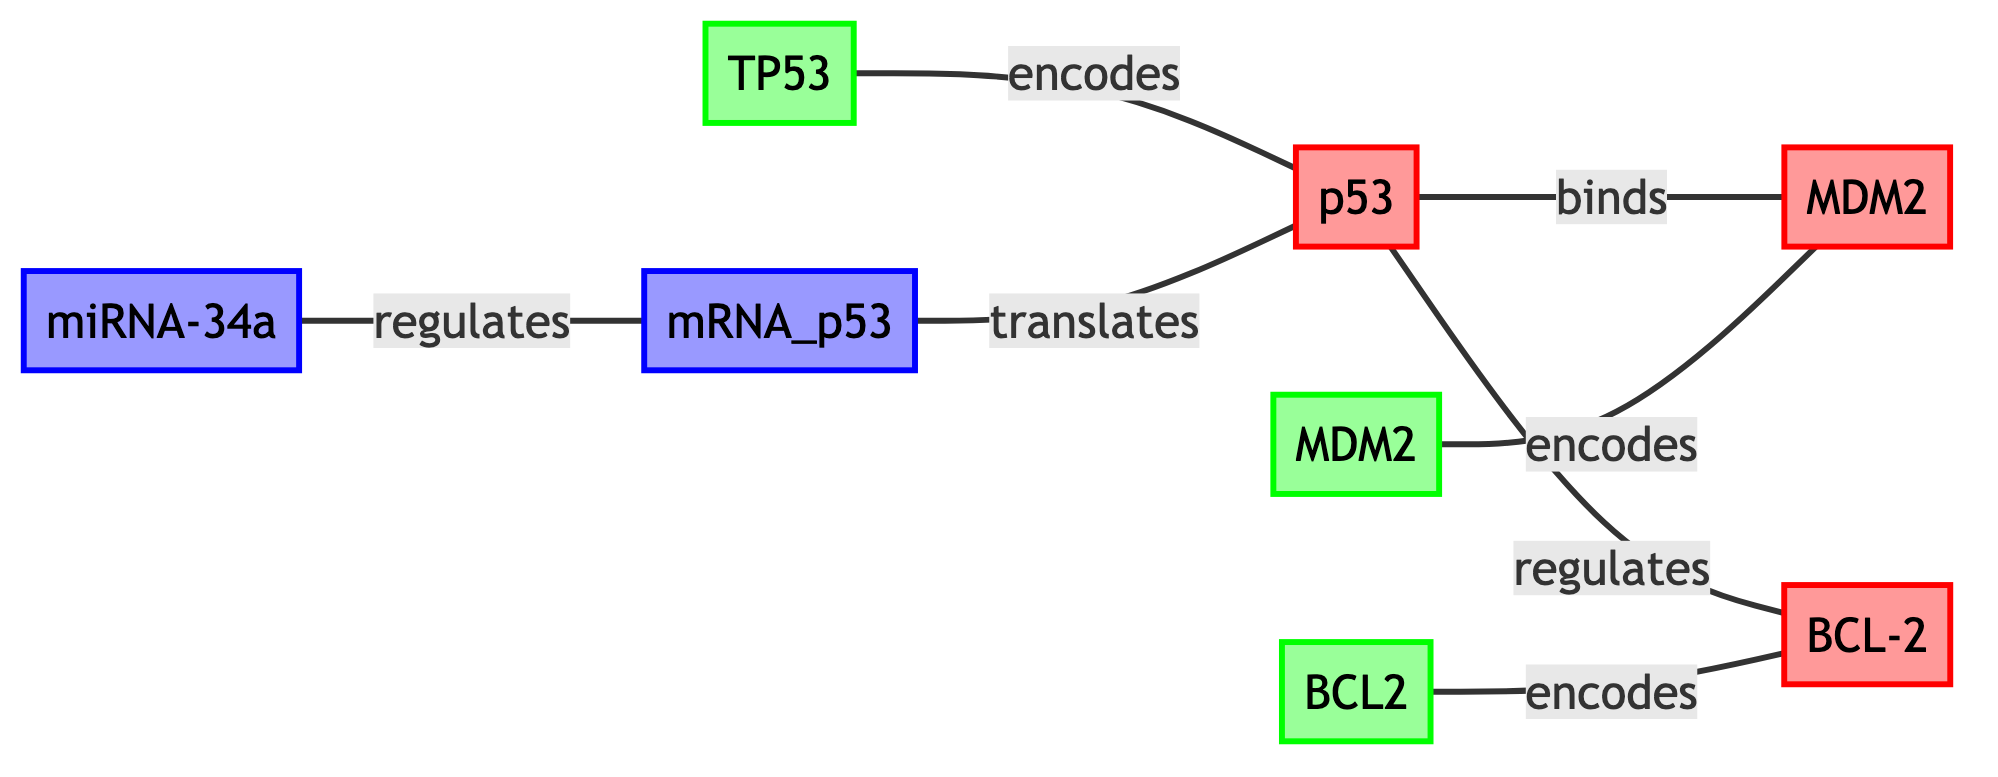What is the total number of nodes in the diagram? To find the total number of nodes, we count each distinct node entry in the data. There are eight nodes in total: Protein_A, Protein_B, Protein_C, Gene_A, Gene_B, Gene_C, RNA_A, and RNA_B.
Answer: 8 Which protein does TP53 encode? The edges indicate that Gene_A encodes Protein_A. Therefore, TP53 encodes p53.
Answer: p53 How many proteins are regulated by p53? The diagram shows that p53 (Protein_A) regulates Protein_C (BCL-2). Thus, p53 regulates one protein.
Answer: 1 What type of interaction occurs between p53 and MDM2? Looking at the interaction displayed in the edges, it states that p53 (Protein_A) binds to MDM2 (Protein_B).
Answer: binds Which RNA regulates mRNA_p53? According to the diagram, RNA_A (miRNA-34a) regulates RNA_B (mRNA_p53).
Answer: miRNA-34a What are the total number of edges in the diagram? We count the edges which represent interactions between the nodes. The diagram has seven edges represented in the data.
Answer: 7 Which gene encodes BCL2? From the edges, we can see that Gene_C encodes Protein_C (BCL-2). Hence, Gene_C encodes BCL2.
Answer: Gene_C How many proteins are involved in the diagram? By looking at the nodes section, we identify the proteins listed: Protein_A, Protein_B, and Protein_C. There are three proteins in total.
Answer: 3 What interaction type links mRNA_p53 and p53? The diagram shows that mRNA_p53 (RNA_B) is translated by Protein_A (p53), indicating a translation interaction.
Answer: translates 